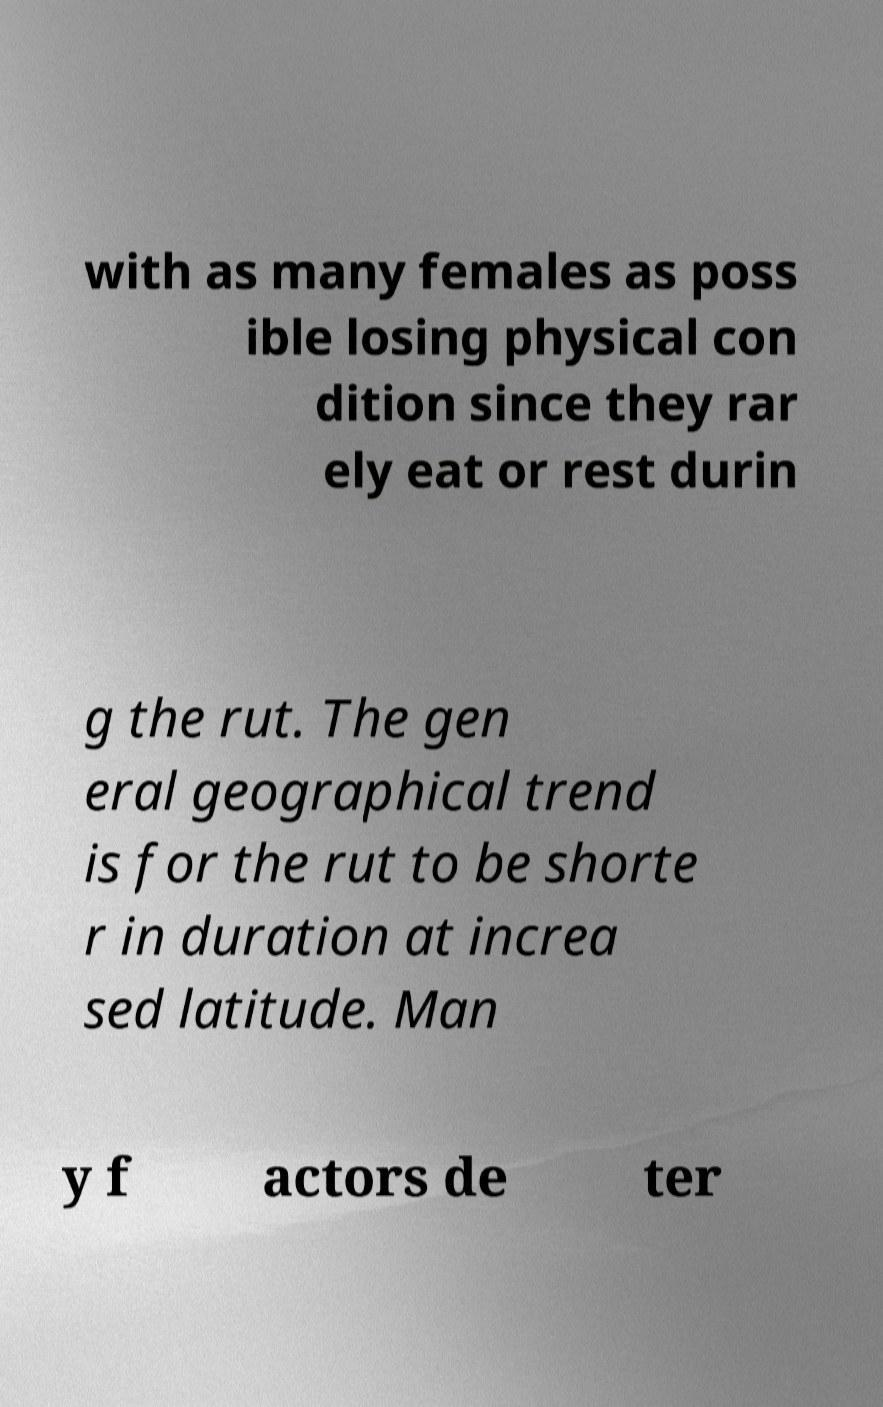There's text embedded in this image that I need extracted. Can you transcribe it verbatim? with as many females as poss ible losing physical con dition since they rar ely eat or rest durin g the rut. The gen eral geographical trend is for the rut to be shorte r in duration at increa sed latitude. Man y f actors de ter 